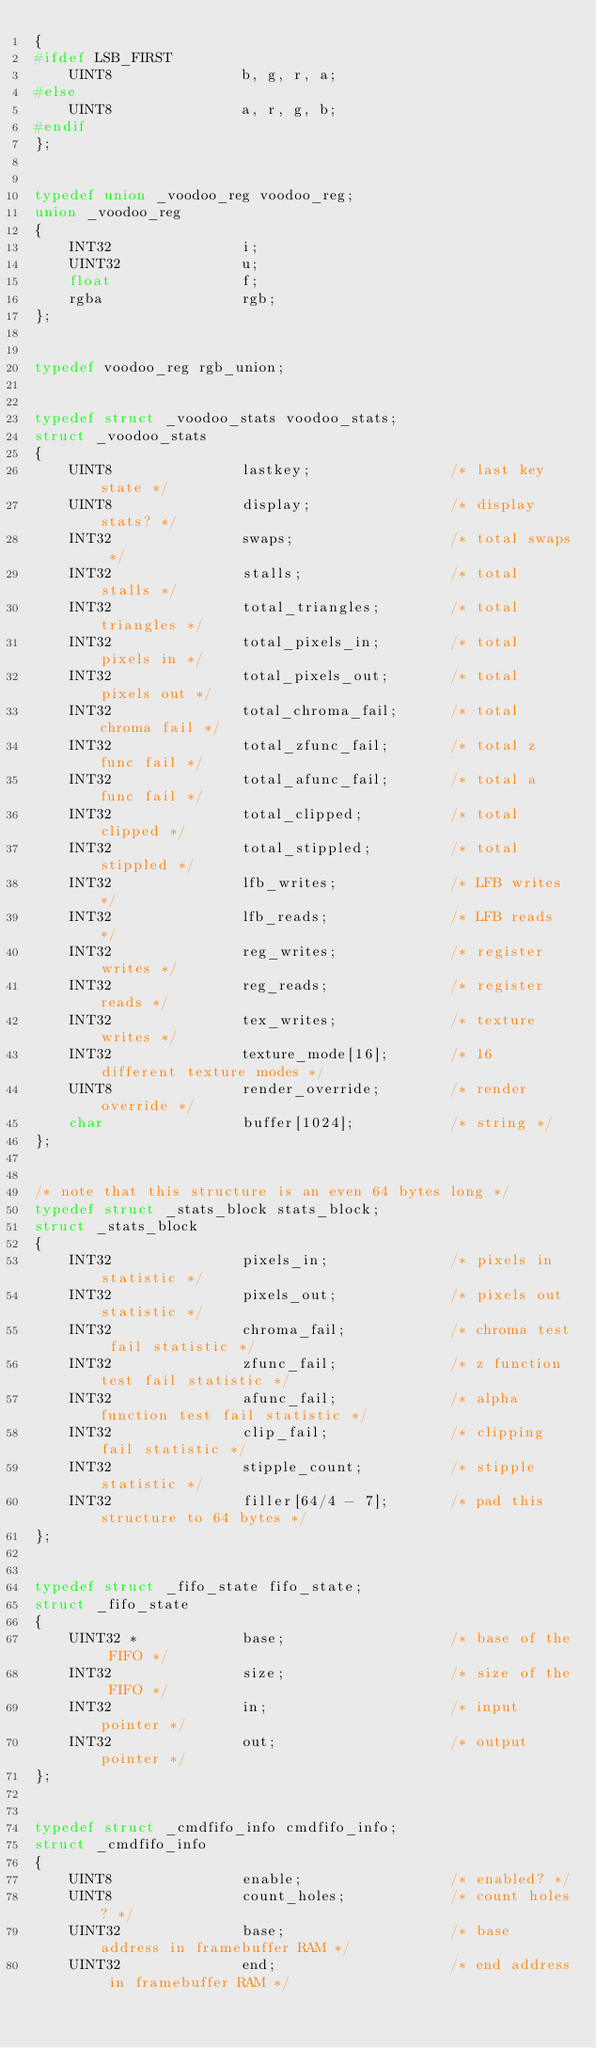<code> <loc_0><loc_0><loc_500><loc_500><_C_>{
#ifdef LSB_FIRST
	UINT8				b, g, r, a;
#else
	UINT8				a, r, g, b;
#endif
};


typedef union _voodoo_reg voodoo_reg;
union _voodoo_reg
{
	INT32				i;
	UINT32				u;
	float				f;
	rgba				rgb;
};


typedef voodoo_reg rgb_union;


typedef struct _voodoo_stats voodoo_stats;
struct _voodoo_stats
{
	UINT8				lastkey;				/* last key state */
	UINT8				display;				/* display stats? */
	INT32				swaps;					/* total swaps */
	INT32				stalls;					/* total stalls */
	INT32				total_triangles;		/* total triangles */
	INT32				total_pixels_in;		/* total pixels in */
	INT32				total_pixels_out;		/* total pixels out */
	INT32				total_chroma_fail;		/* total chroma fail */
	INT32				total_zfunc_fail;		/* total z func fail */
	INT32				total_afunc_fail;		/* total a func fail */
	INT32				total_clipped;			/* total clipped */
	INT32				total_stippled;			/* total stippled */
	INT32				lfb_writes;				/* LFB writes */
	INT32				lfb_reads;				/* LFB reads */
	INT32				reg_writes;				/* register writes */
	INT32				reg_reads;				/* register reads */
	INT32				tex_writes;				/* texture writes */
	INT32				texture_mode[16];		/* 16 different texture modes */
	UINT8				render_override;		/* render override */
	char				buffer[1024];			/* string */
};


/* note that this structure is an even 64 bytes long */
typedef struct _stats_block stats_block;
struct _stats_block
{
	INT32				pixels_in;				/* pixels in statistic */
	INT32				pixels_out;				/* pixels out statistic */
	INT32				chroma_fail;			/* chroma test fail statistic */
	INT32				zfunc_fail;				/* z function test fail statistic */
	INT32				afunc_fail;				/* alpha function test fail statistic */
	INT32				clip_fail;				/* clipping fail statistic */
	INT32				stipple_count;			/* stipple statistic */
	INT32				filler[64/4 - 7];		/* pad this structure to 64 bytes */
};


typedef struct _fifo_state fifo_state;
struct _fifo_state
{
	UINT32 *			base;					/* base of the FIFO */
	INT32				size;					/* size of the FIFO */
	INT32				in;						/* input pointer */
	INT32				out;					/* output pointer */
};


typedef struct _cmdfifo_info cmdfifo_info;
struct _cmdfifo_info
{
	UINT8				enable;					/* enabled? */
	UINT8				count_holes;			/* count holes? */
	UINT32				base;					/* base address in framebuffer RAM */
	UINT32				end;					/* end address in framebuffer RAM */</code> 